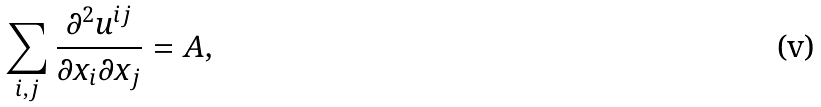Convert formula to latex. <formula><loc_0><loc_0><loc_500><loc_500>\sum _ { i , j } \frac { \partial ^ { 2 } u ^ { i j } } { \partial x _ { i } \partial x _ { j } } = A ,</formula> 